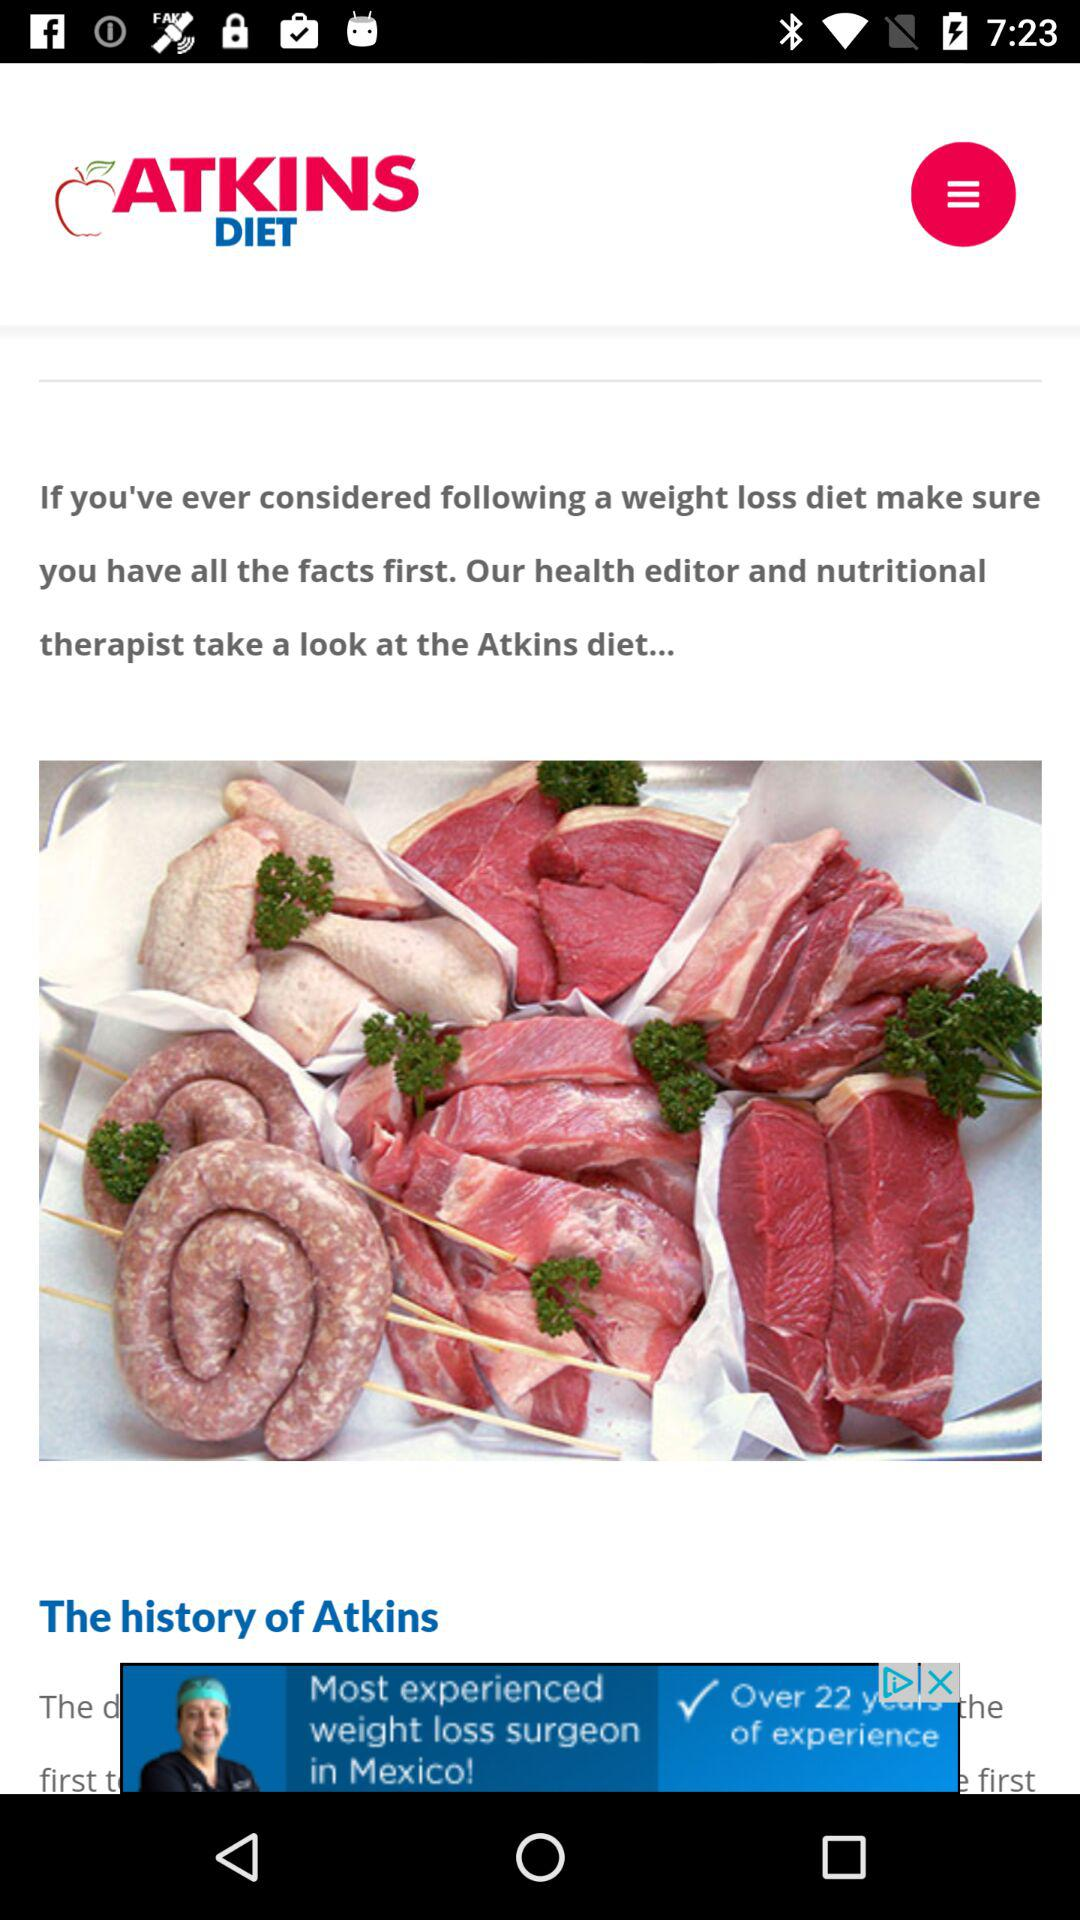What is the application name? The application name is "ATKINS DIET". 